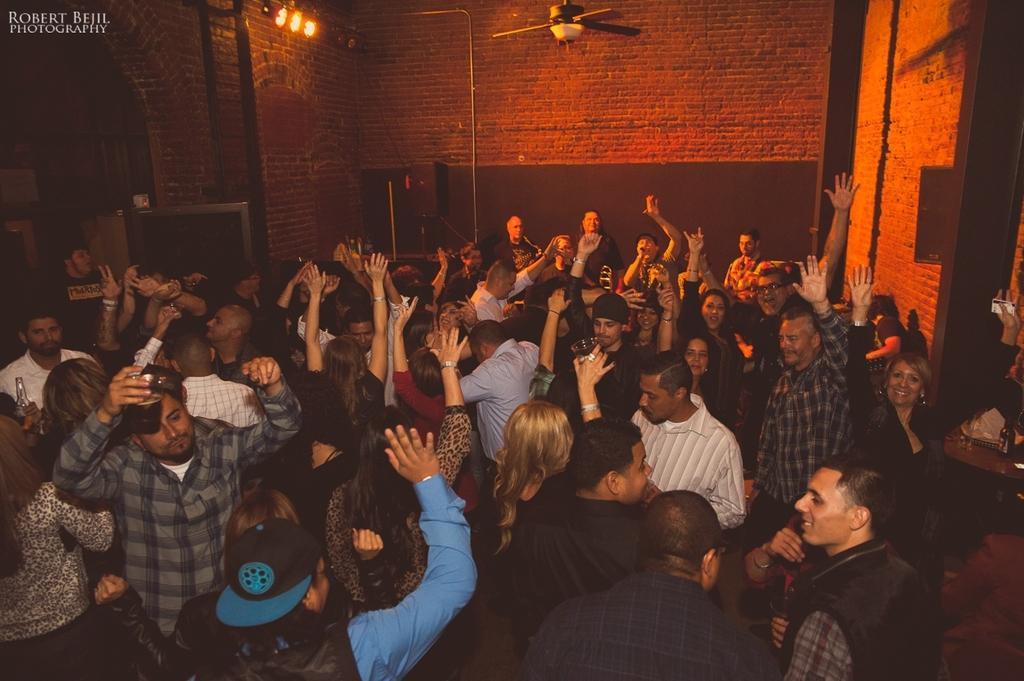Describe this image in one or two sentences. In this image there are group of people dancing, and there are lights, fan and a watermark on the image. 